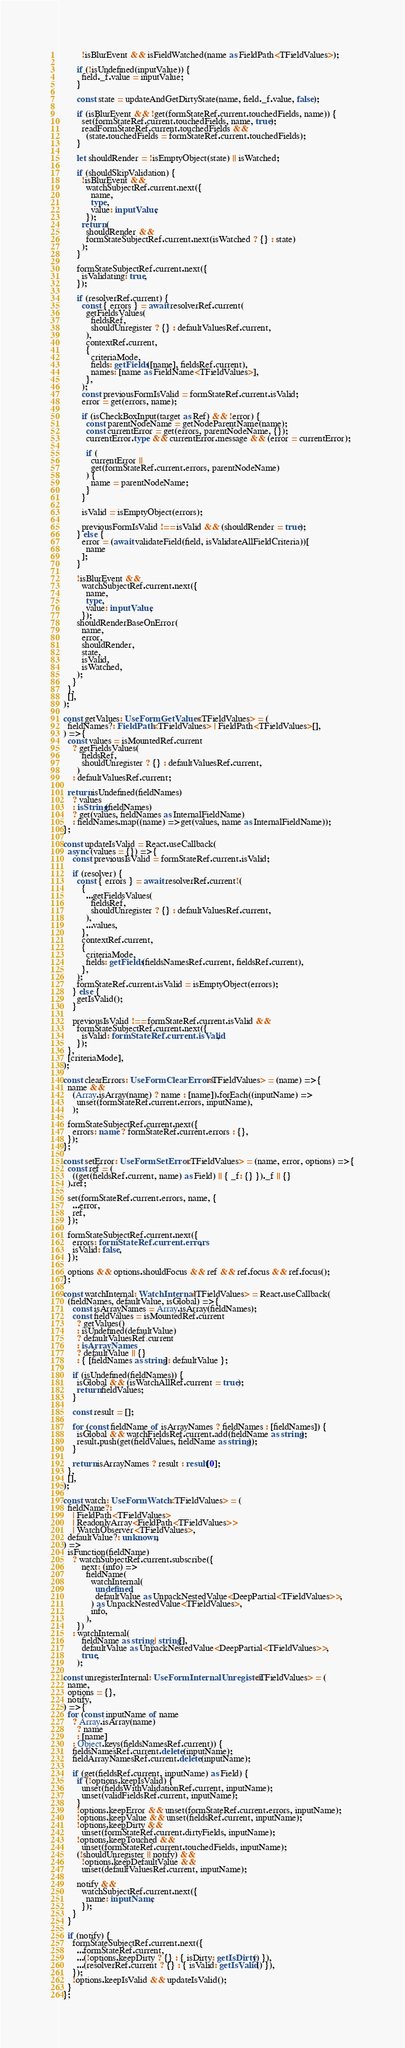<code> <loc_0><loc_0><loc_500><loc_500><_TypeScript_>          !isBlurEvent && isFieldWatched(name as FieldPath<TFieldValues>);

        if (!isUndefined(inputValue)) {
          field._f.value = inputValue;
        }

        const state = updateAndGetDirtyState(name, field._f.value, false);

        if (isBlurEvent && !get(formStateRef.current.touchedFields, name)) {
          set(formStateRef.current.touchedFields, name, true);
          readFormStateRef.current.touchedFields &&
            (state.touchedFields = formStateRef.current.touchedFields);
        }

        let shouldRender = !isEmptyObject(state) || isWatched;

        if (shouldSkipValidation) {
          !isBlurEvent &&
            watchSubjectRef.current.next({
              name,
              type,
              value: inputValue,
            });
          return (
            shouldRender &&
            formStateSubjectRef.current.next(isWatched ? {} : state)
          );
        }

        formStateSubjectRef.current.next({
          isValidating: true,
        });

        if (resolverRef.current) {
          const { errors } = await resolverRef.current(
            getFieldsValues(
              fieldsRef,
              shouldUnregister ? {} : defaultValuesRef.current,
            ),
            contextRef.current,
            {
              criteriaMode,
              fields: getFields([name], fieldsRef.current),
              names: [name as FieldName<TFieldValues>],
            },
          );
          const previousFormIsValid = formStateRef.current.isValid;
          error = get(errors, name);

          if (isCheckBoxInput(target as Ref) && !error) {
            const parentNodeName = getNodeParentName(name);
            const currentError = get(errors, parentNodeName, {});
            currentError.type && currentError.message && (error = currentError);

            if (
              currentError ||
              get(formStateRef.current.errors, parentNodeName)
            ) {
              name = parentNodeName;
            }
          }

          isValid = isEmptyObject(errors);

          previousFormIsValid !== isValid && (shouldRender = true);
        } else {
          error = (await validateField(field, isValidateAllFieldCriteria))[
            name
          ];
        }

        !isBlurEvent &&
          watchSubjectRef.current.next({
            name,
            type,
            value: inputValue,
          });
        shouldRenderBaseOnError(
          name,
          error,
          shouldRender,
          state,
          isValid,
          isWatched,
        );
      }
    },
    [],
  );

  const getValues: UseFormGetValues<TFieldValues> = (
    fieldNames?: FieldPath<TFieldValues> | FieldPath<TFieldValues>[],
  ) => {
    const values = isMountedRef.current
      ? getFieldsValues(
          fieldsRef,
          shouldUnregister ? {} : defaultValuesRef.current,
        )
      : defaultValuesRef.current;

    return isUndefined(fieldNames)
      ? values
      : isString(fieldNames)
      ? get(values, fieldNames as InternalFieldName)
      : fieldNames.map((name) => get(values, name as InternalFieldName));
  };

  const updateIsValid = React.useCallback(
    async (values = {}) => {
      const previousIsValid = formStateRef.current.isValid;

      if (resolver) {
        const { errors } = await resolverRef.current!(
          {
            ...getFieldsValues(
              fieldsRef,
              shouldUnregister ? {} : defaultValuesRef.current,
            ),
            ...values,
          },
          contextRef.current,
          {
            criteriaMode,
            fields: getFields(fieldsNamesRef.current, fieldsRef.current),
          },
        );
        formStateRef.current.isValid = isEmptyObject(errors);
      } else {
        getIsValid();
      }

      previousIsValid !== formStateRef.current.isValid &&
        formStateSubjectRef.current.next({
          isValid: formStateRef.current.isValid,
        });
    },
    [criteriaMode],
  );

  const clearErrors: UseFormClearErrors<TFieldValues> = (name) => {
    name &&
      (Array.isArray(name) ? name : [name]).forEach((inputName) =>
        unset(formStateRef.current.errors, inputName),
      );

    formStateSubjectRef.current.next({
      errors: name ? formStateRef.current.errors : {},
    });
  };

  const setError: UseFormSetError<TFieldValues> = (name, error, options) => {
    const ref = (
      ((get(fieldsRef.current, name) as Field) || { _f: {} })._f || {}
    ).ref;

    set(formStateRef.current.errors, name, {
      ...error,
      ref,
    });

    formStateSubjectRef.current.next({
      errors: formStateRef.current.errors,
      isValid: false,
    });

    options && options.shouldFocus && ref && ref.focus && ref.focus();
  };

  const watchInternal: WatchInternal<TFieldValues> = React.useCallback(
    (fieldNames, defaultValue, isGlobal) => {
      const isArrayNames = Array.isArray(fieldNames);
      const fieldValues = isMountedRef.current
        ? getValues()
        : isUndefined(defaultValue)
        ? defaultValuesRef.current
        : isArrayNames
        ? defaultValue || {}
        : { [fieldNames as string]: defaultValue };

      if (isUndefined(fieldNames)) {
        isGlobal && (isWatchAllRef.current = true);
        return fieldValues;
      }

      const result = [];

      for (const fieldName of isArrayNames ? fieldNames : [fieldNames]) {
        isGlobal && watchFieldsRef.current.add(fieldName as string);
        result.push(get(fieldValues, fieldName as string));
      }

      return isArrayNames ? result : result[0];
    },
    [],
  );

  const watch: UseFormWatch<TFieldValues> = (
    fieldName?:
      | FieldPath<TFieldValues>
      | ReadonlyArray<FieldPath<TFieldValues>>
      | WatchObserver<TFieldValues>,
    defaultValue?: unknown,
  ) =>
    isFunction(fieldName)
      ? watchSubjectRef.current.subscribe({
          next: (info) =>
            fieldName(
              watchInternal(
                undefined,
                defaultValue as UnpackNestedValue<DeepPartial<TFieldValues>>,
              ) as UnpackNestedValue<TFieldValues>,
              info,
            ),
        })
      : watchInternal(
          fieldName as string | string[],
          defaultValue as UnpackNestedValue<DeepPartial<TFieldValues>>,
          true,
        );

  const unregisterInternal: UseFormInternalUnregister<TFieldValues> = (
    name,
    options = {},
    notify,
  ) => {
    for (const inputName of name
      ? Array.isArray(name)
        ? name
        : [name]
      : Object.keys(fieldsNamesRef.current)) {
      fieldsNamesRef.current.delete(inputName);
      fieldArrayNamesRef.current.delete(inputName);

      if (get(fieldsRef.current, inputName) as Field) {
        if (!options.keepIsValid) {
          unset(fieldsWithValidationRef.current, inputName);
          unset(validFieldsRef.current, inputName);
        }
        !options.keepError && unset(formStateRef.current.errors, inputName);
        !options.keepValue && unset(fieldsRef.current, inputName);
        !options.keepDirty &&
          unset(formStateRef.current.dirtyFields, inputName);
        !options.keepTouched &&
          unset(formStateRef.current.touchedFields, inputName);
        (!shouldUnregister || notify) &&
          !options.keepDefaultValue &&
          unset(defaultValuesRef.current, inputName);

        notify &&
          watchSubjectRef.current.next({
            name: inputName,
          });
      }
    }

    if (notify) {
      formStateSubjectRef.current.next({
        ...formStateRef.current,
        ...(!options.keepDirty ? {} : { isDirty: getIsDirty() }),
        ...(resolverRef.current ? {} : { isValid: getIsValid() }),
      });
      !options.keepIsValid && updateIsValid();
    }
  };
</code> 